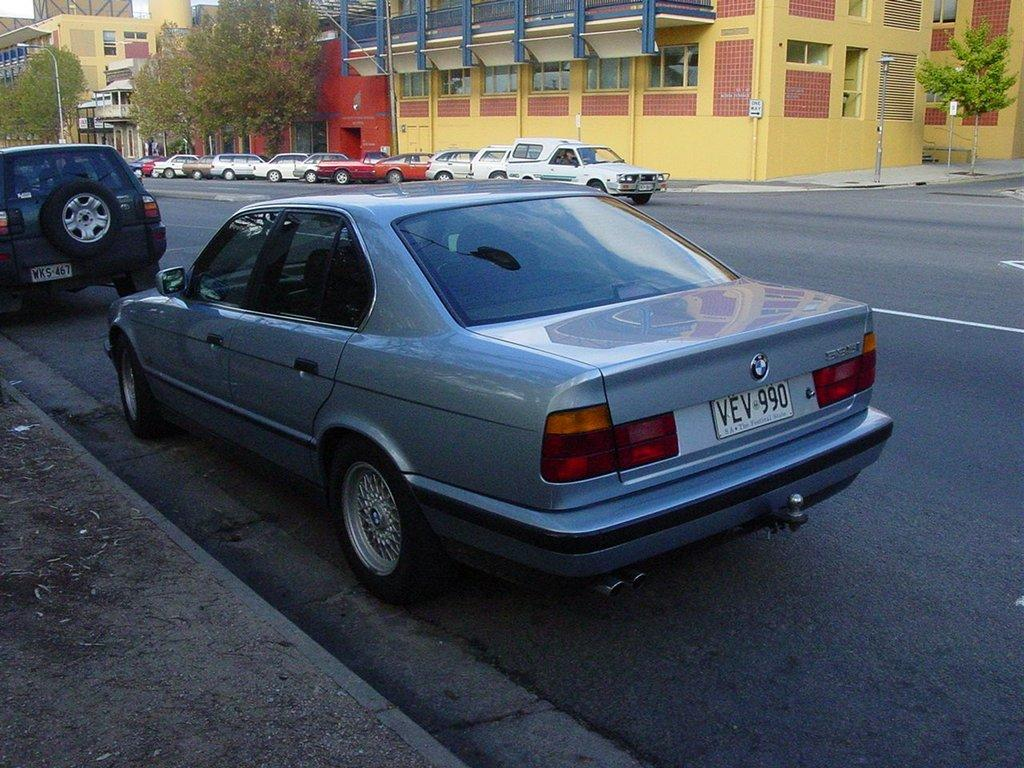What is happening on the road in the image? There are vehicles on the road in the image. What can be seen in the distance behind the vehicles? There are buildings, pole lights, trees, and other objects in the background of the image. Can you describe the lighting in the image? Pole lights are present in the background of the image. What type of paint is being used to create the stew in the image? There is no paint or stew present in the image; it features vehicles on a road with buildings and other objects in the background. 